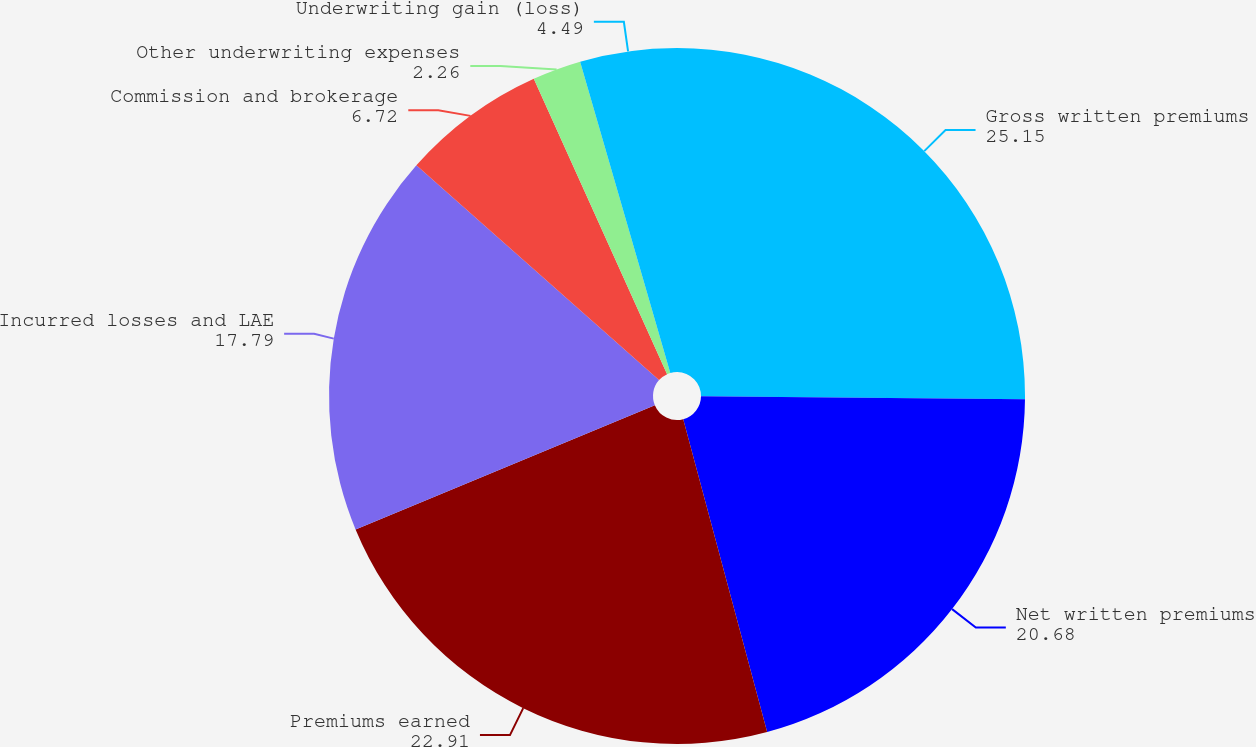Convert chart to OTSL. <chart><loc_0><loc_0><loc_500><loc_500><pie_chart><fcel>Gross written premiums<fcel>Net written premiums<fcel>Premiums earned<fcel>Incurred losses and LAE<fcel>Commission and brokerage<fcel>Other underwriting expenses<fcel>Underwriting gain (loss)<nl><fcel>25.15%<fcel>20.68%<fcel>22.91%<fcel>17.79%<fcel>6.72%<fcel>2.26%<fcel>4.49%<nl></chart> 